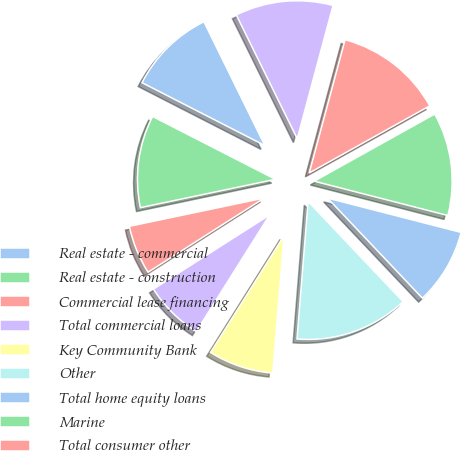Convert chart. <chart><loc_0><loc_0><loc_500><loc_500><pie_chart><fcel>Real estate - commercial<fcel>Real estate - construction<fcel>Commercial lease financing<fcel>Total commercial loans<fcel>Key Community Bank<fcel>Other<fcel>Total home equity loans<fcel>Marine<fcel>Total consumer other<fcel>Total consumer loans<nl><fcel>10.19%<fcel>10.82%<fcel>5.75%<fcel>7.02%<fcel>7.65%<fcel>13.36%<fcel>8.92%<fcel>12.09%<fcel>12.73%<fcel>11.46%<nl></chart> 